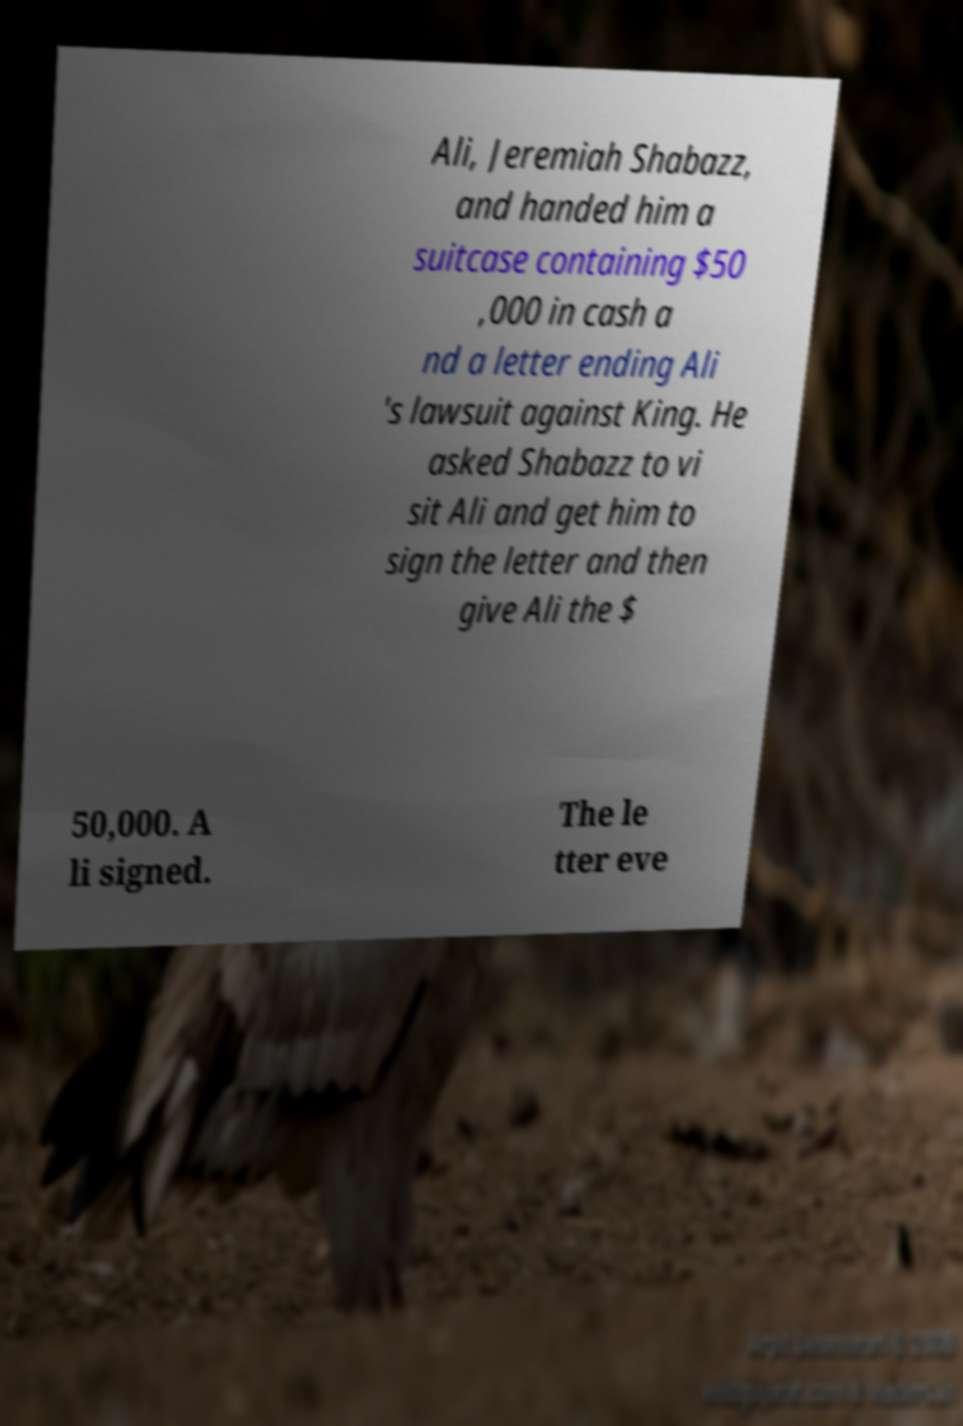Can you read and provide the text displayed in the image?This photo seems to have some interesting text. Can you extract and type it out for me? Ali, Jeremiah Shabazz, and handed him a suitcase containing $50 ,000 in cash a nd a letter ending Ali 's lawsuit against King. He asked Shabazz to vi sit Ali and get him to sign the letter and then give Ali the $ 50,000. A li signed. The le tter eve 